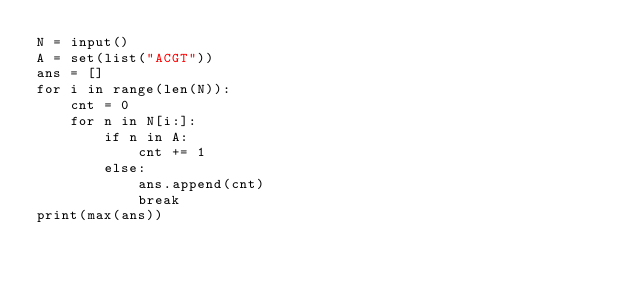<code> <loc_0><loc_0><loc_500><loc_500><_Python_>N = input()
A = set(list("ACGT"))
ans = []
for i in range(len(N)):
    cnt = 0
    for n in N[i:]:
        if n in A:
            cnt += 1
        else:
            ans.append(cnt)
            break
print(max(ans))</code> 